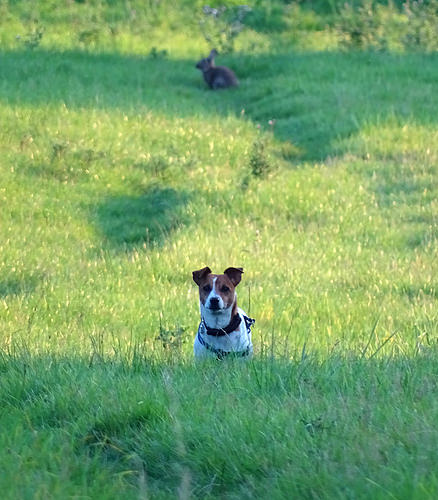<image>
Is the rabbit above the dog? No. The rabbit is not positioned above the dog. The vertical arrangement shows a different relationship. 